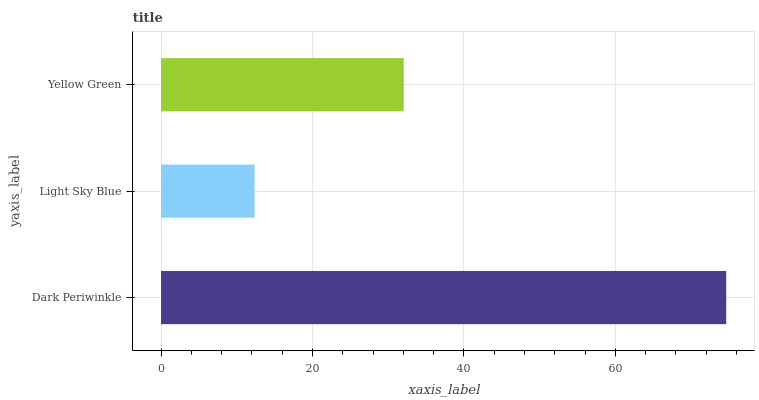Is Light Sky Blue the minimum?
Answer yes or no. Yes. Is Dark Periwinkle the maximum?
Answer yes or no. Yes. Is Yellow Green the minimum?
Answer yes or no. No. Is Yellow Green the maximum?
Answer yes or no. No. Is Yellow Green greater than Light Sky Blue?
Answer yes or no. Yes. Is Light Sky Blue less than Yellow Green?
Answer yes or no. Yes. Is Light Sky Blue greater than Yellow Green?
Answer yes or no. No. Is Yellow Green less than Light Sky Blue?
Answer yes or no. No. Is Yellow Green the high median?
Answer yes or no. Yes. Is Yellow Green the low median?
Answer yes or no. Yes. Is Dark Periwinkle the high median?
Answer yes or no. No. Is Dark Periwinkle the low median?
Answer yes or no. No. 